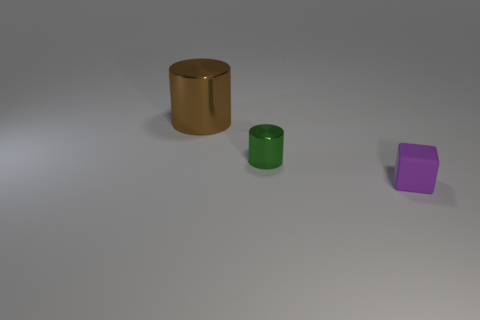Subtract all cubes. How many objects are left? 2 Subtract all green cylinders. How many cylinders are left? 1 Subtract 0 red cylinders. How many objects are left? 3 Subtract all brown cubes. Subtract all purple balls. How many cubes are left? 1 Subtract all blue cylinders. How many gray cubes are left? 0 Subtract all large red shiny blocks. Subtract all tiny green shiny cylinders. How many objects are left? 2 Add 2 green objects. How many green objects are left? 3 Add 1 big blue shiny balls. How many big blue shiny balls exist? 1 Add 1 tiny matte things. How many objects exist? 4 